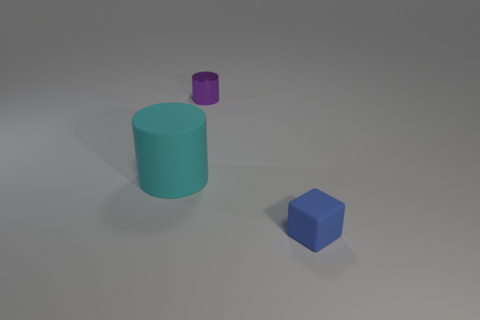Do the object on the left side of the purple metallic thing and the tiny blue thing have the same material?
Your answer should be compact. Yes. There is a large rubber object that is the same shape as the tiny purple metal thing; what color is it?
Make the answer very short. Cyan. There is a tiny blue matte object; what shape is it?
Provide a succinct answer. Cube. What number of things are small purple metallic things or large rubber objects?
Your answer should be very brief. 2. Is the color of the small object that is in front of the small metal cylinder the same as the tiny thing behind the tiny blue rubber cube?
Offer a terse response. No. How many other things are there of the same shape as the blue matte object?
Keep it short and to the point. 0. Is there a tiny blue matte cube?
Ensure brevity in your answer.  Yes. What number of objects are either big cylinders or tiny objects that are on the right side of the small metal object?
Make the answer very short. 2. Is the size of the cylinder on the right side of the cyan matte cylinder the same as the large cyan rubber cylinder?
Offer a very short reply. No. What number of other things are there of the same size as the rubber block?
Your answer should be compact. 1. 